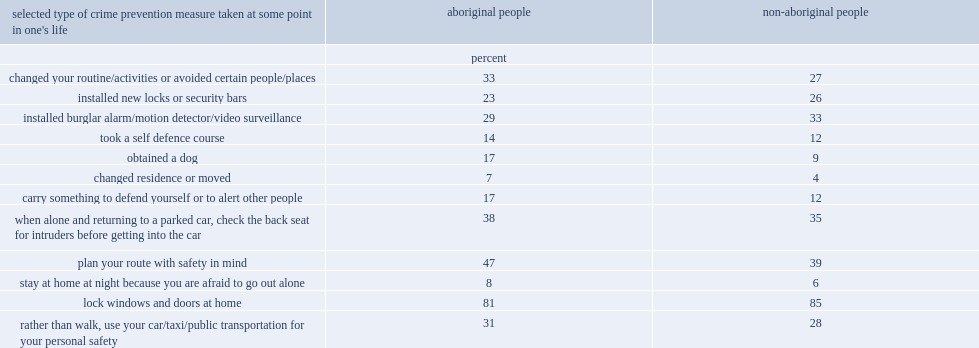What were the percentages of aboriginal people who said they changed their routine or activities or avoided certain people or places and who said they obtained a dog to protect them from crime respectively? 33.0 17.0. What were the percentages of non-aboriginal people who said they changed their routine or activities or avoided certain people or places and who said they obtained a dog to protect them from crime respectively? 27.0 9.0. Would you mind parsing the complete table? {'header': ["selected type of crime prevention measure taken at some point in one's life", 'aboriginal people', 'non-aboriginal people'], 'rows': [['', 'percent', ''], ['changed your routine/activities or avoided certain people/places', '33', '27'], ['installed new locks or security bars', '23', '26'], ['installed burglar alarm/motion detector/video surveillance', '29', '33'], ['took a self defence course', '14', '12'], ['obtained a dog', '17', '9'], ['changed residence or moved', '7', '4'], ['carry something to defend yourself or to alert other people', '17', '12'], ['when alone and returning to a parked car, check the back seat for intruders before getting into the car', '38', '35'], ['plan your route with safety in mind', '47', '39'], ['stay at home at night because you are afraid to go out alone', '8', '6'], ['lock windows and doors at home', '81', '85'], ['rather than walk, use your car/taxi/public transportation for your personal safety', '31', '28']]} 